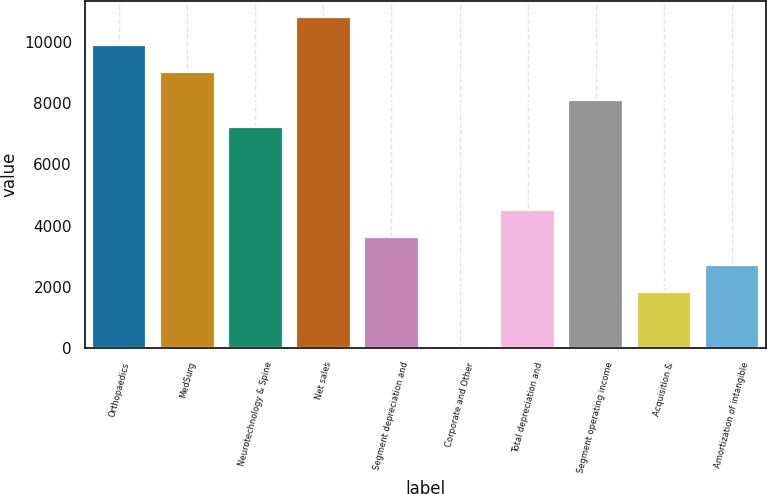<chart> <loc_0><loc_0><loc_500><loc_500><bar_chart><fcel>Orthopaedics<fcel>MedSurg<fcel>Neurotechnology & Spine<fcel>Net sales<fcel>Segment depreciation and<fcel>Corporate and Other<fcel>Total depreciation and<fcel>Segment operating income<fcel>Acquisition &<fcel>Amortization of intangible<nl><fcel>9921.2<fcel>9021<fcel>7220.6<fcel>10821.4<fcel>3619.8<fcel>19<fcel>4520<fcel>8120.8<fcel>1819.4<fcel>2719.6<nl></chart> 